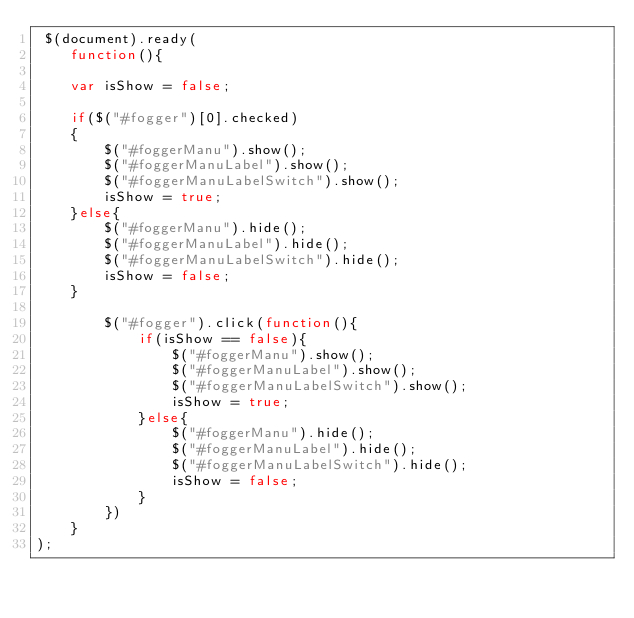<code> <loc_0><loc_0><loc_500><loc_500><_JavaScript_> $(document).ready(
	function(){
	
	var isShow = false;
	
	if($("#fogger")[0].checked)
	{
		$("#foggerManu").show(); 
		$("#foggerManuLabel").show(); 
		$("#foggerManuLabelSwitch").show(); 
		isShow = true;
	}else{
		$("#foggerManu").hide();
		$("#foggerManuLabel").hide();  
		$("#foggerManuLabelSwitch").hide(); 
		isShow = false;
	}
	
		$("#fogger").click(function(){
			if(isShow == false){
				$("#foggerManu").show(); 
				$("#foggerManuLabel").show(); 
				$("#foggerManuLabelSwitch").show(); 
				isShow = true;
			}else{
				$("#foggerManu").hide();
				$("#foggerManuLabel").hide(); 
				$("#foggerManuLabelSwitch").hide(); 
				isShow = false;
			}
		})
	}
);
</code> 